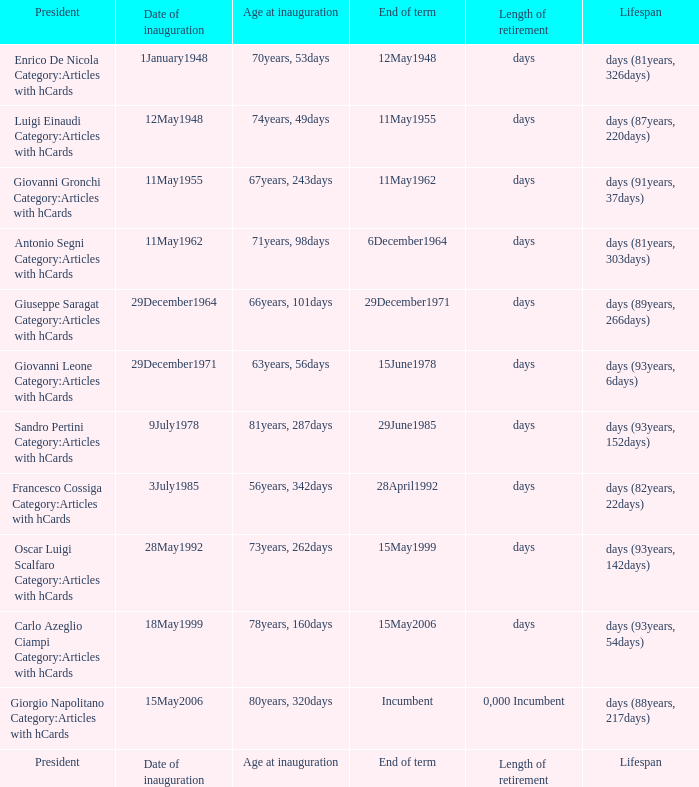For a president who took office at the age of 78 years and 160 days, when does their term conclude? 15May2006. 